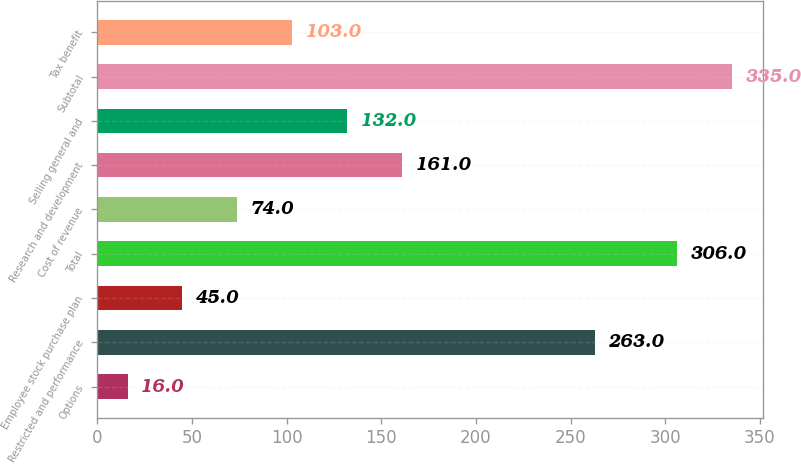Convert chart. <chart><loc_0><loc_0><loc_500><loc_500><bar_chart><fcel>Options<fcel>Restricted and performance<fcel>Employee stock purchase plan<fcel>Total<fcel>Cost of revenue<fcel>Research and development<fcel>Selling general and<fcel>Subtotal<fcel>Tax benefit<nl><fcel>16<fcel>263<fcel>45<fcel>306<fcel>74<fcel>161<fcel>132<fcel>335<fcel>103<nl></chart> 